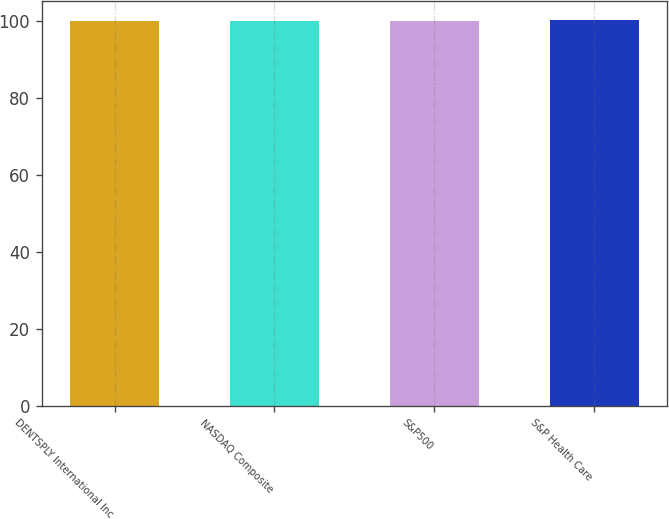<chart> <loc_0><loc_0><loc_500><loc_500><bar_chart><fcel>DENTSPLY International Inc<fcel>NASDAQ Composite<fcel>S&P500<fcel>S&P Health Care<nl><fcel>100<fcel>100.1<fcel>100.2<fcel>100.3<nl></chart> 